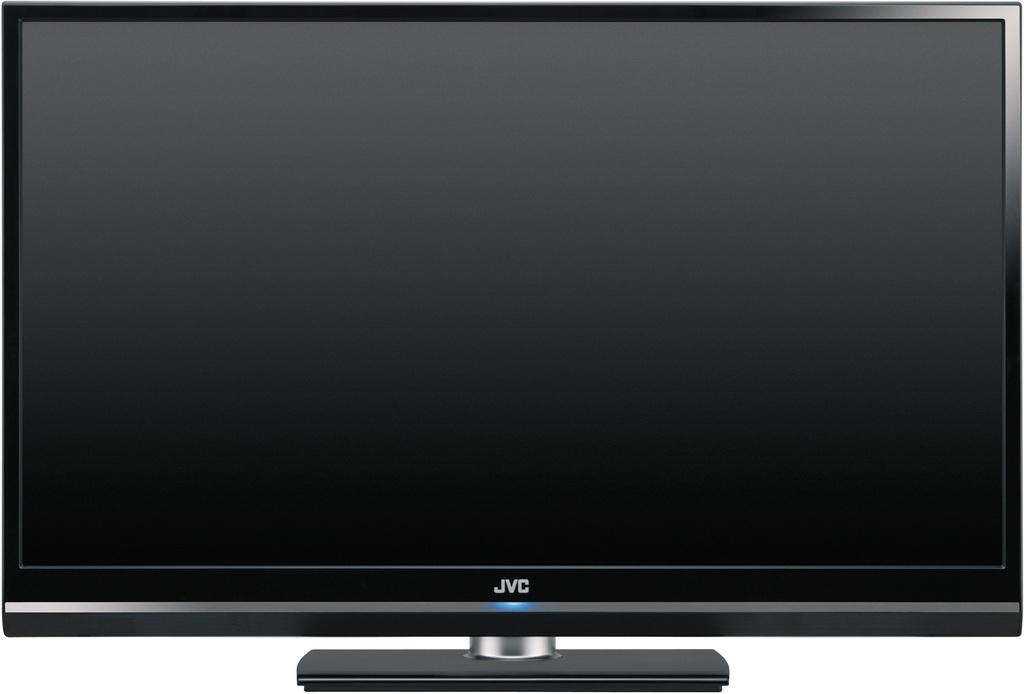<image>
Render a clear and concise summary of the photo. A thin black JVC flat screen is being shown in the picture. 